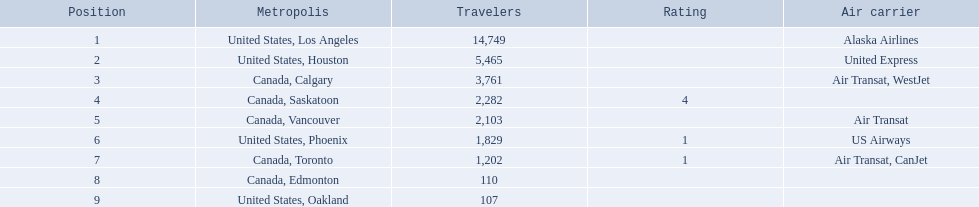What are the cities flown to? United States, Los Angeles, United States, Houston, Canada, Calgary, Canada, Saskatoon, Canada, Vancouver, United States, Phoenix, Canada, Toronto, Canada, Edmonton, United States, Oakland. What number of passengers did pheonix have? 1,829. Where are the destinations of the airport? United States, Los Angeles, United States, Houston, Canada, Calgary, Canada, Saskatoon, Canada, Vancouver, United States, Phoenix, Canada, Toronto, Canada, Edmonton, United States, Oakland. What is the number of passengers to phoenix? 1,829. 